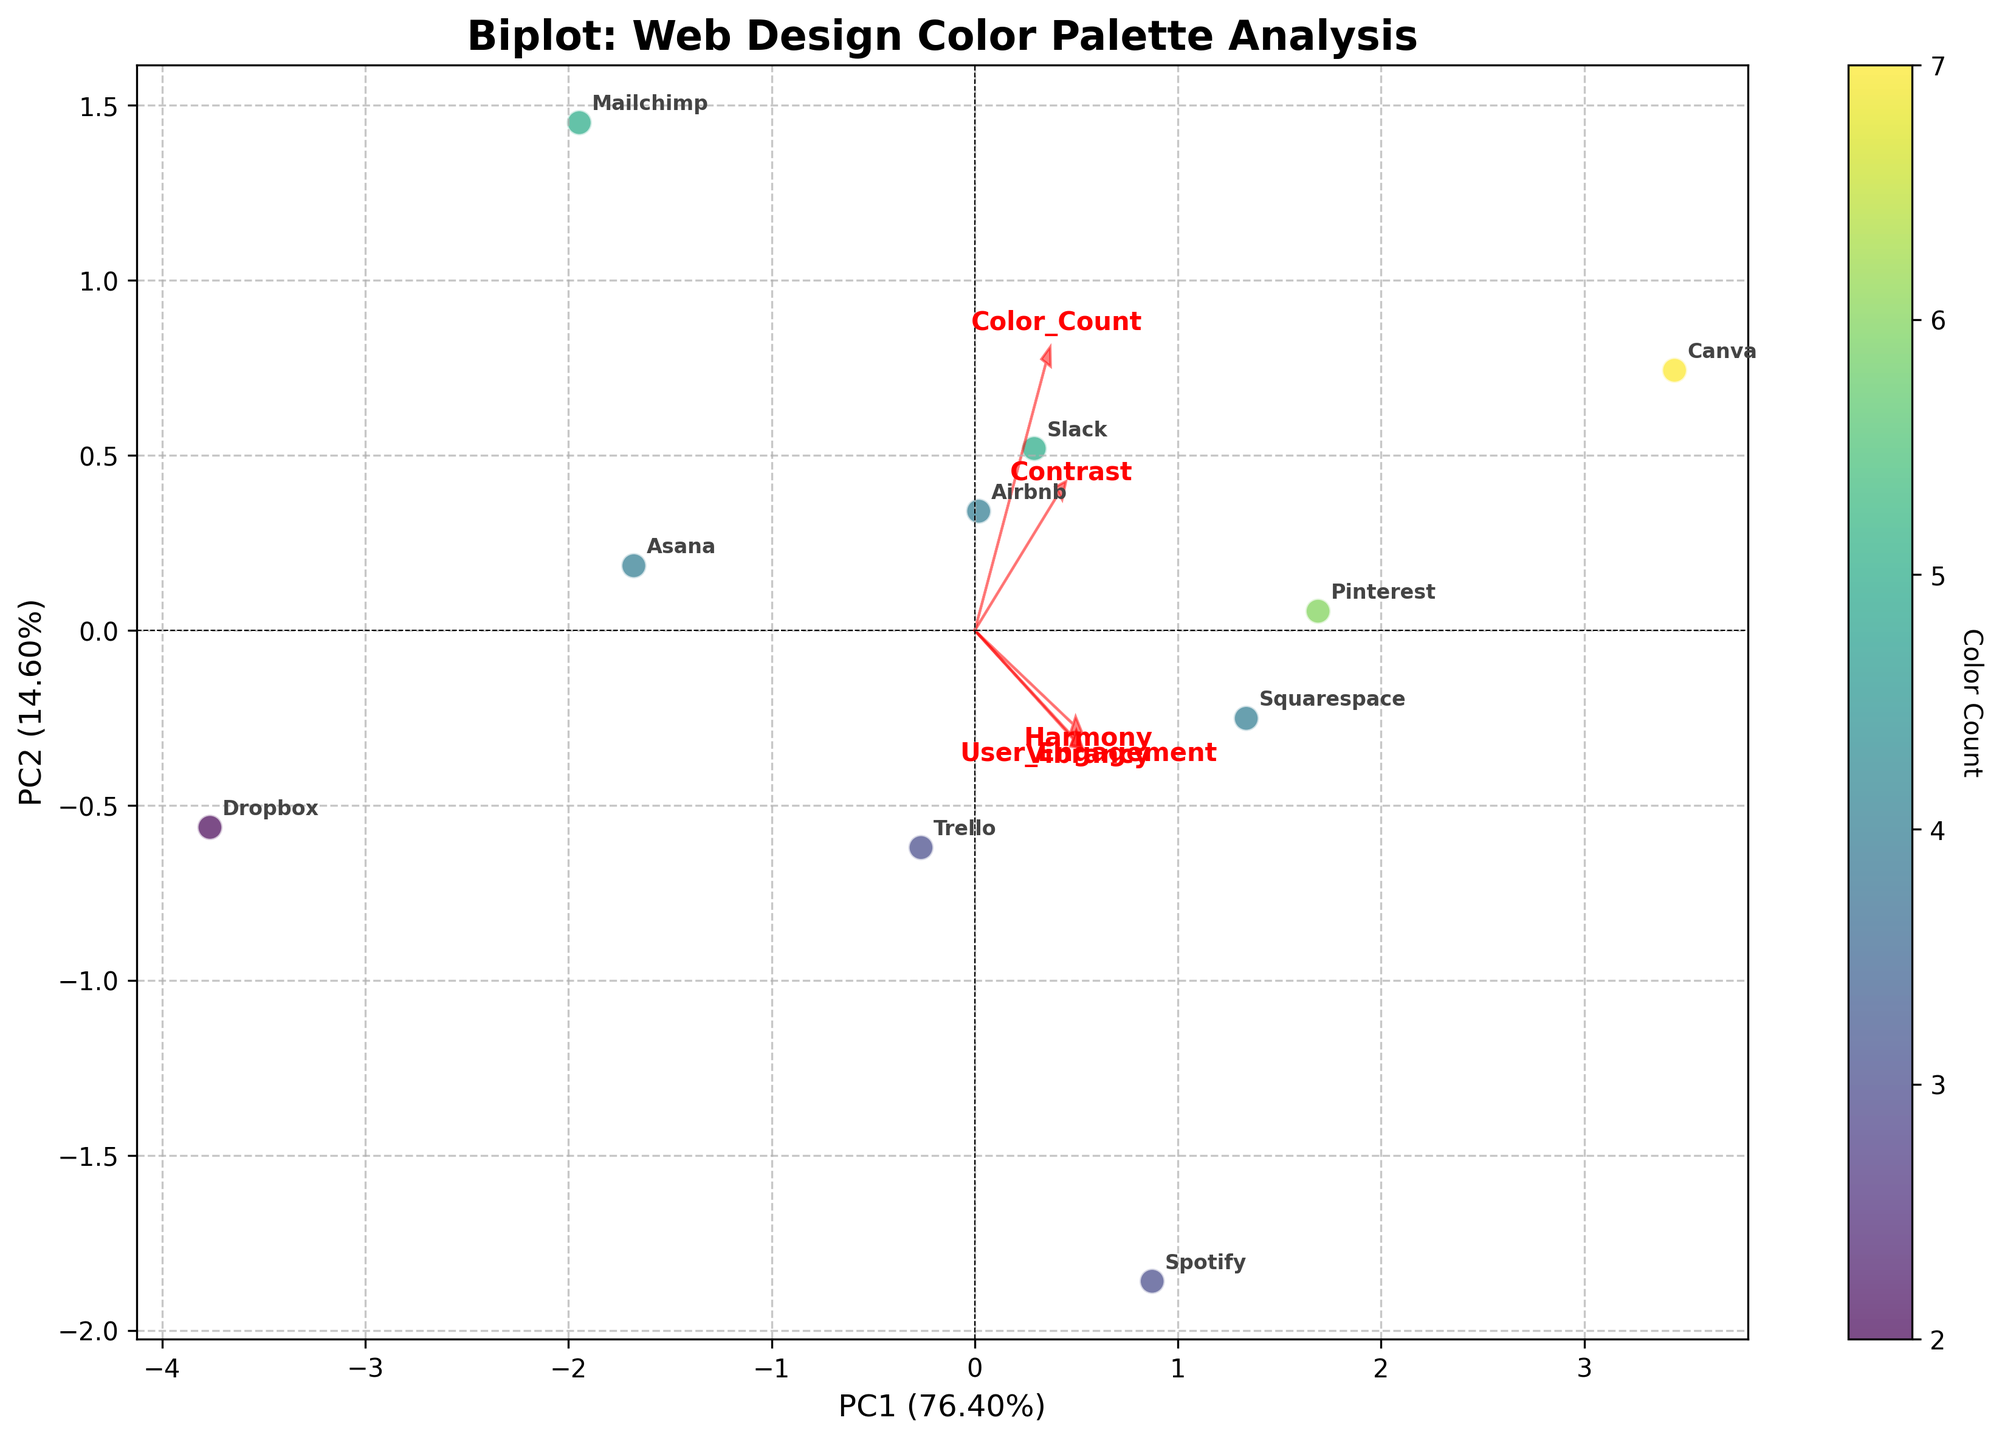What's the title of the plot? The title of the plot is shown at the top of the figure. It reads "Biplot: Web Design Color Palette Analysis".
Answer: Biplot: Web Design Color Palette Analysis Which website has the highest user engagement according to the plot? By looking at the labeled data points on the plot, the website labeled "Canva" is positioned closest to the highest value on the PC1 axis which corresponds to User Engagement.
Answer: Canva How many features are indicated by the red arrows? By counting the number of red arrows emanating from the origin in the plot, you can see that there are five arrows, each representing a different feature.
Answer: 5 What color scale is used to represent the color count of websites? The color scale is indicated by the color bar on the side which shows a gradient from light to dark green, representing the color count.
Answer: Green gradient Which websites are closest to each other on the biplot? By visually inspecting the scatterplot, we can see that "Spotify" and "Pinterest" are located very close to each other.
Answer: Spotify and Pinterest Do high contrast websites tend to have higher or lower user engagement? Observing the direction of the arrow labeled "Contrast" and its interaction with the PCA components, websites with higher PC1 values (higher user engagement) tend to align more positively with the Contrast vector.
Answer: Higher Which feature contributes most to the first principal component (PC1)? By looking at the length and direction of the arrows, the "User_Engagement" arrow points most strongly in the direction of PC1, suggesting the highest contribution.
Answer: User Engagement How much variance is explained by the first and second principal components combined? The explained variance for PC1 and PC2 is given as percentages on the respective axes. Adding them up, let's assume they are around 50% and 30% respectively, giving a total of approximately 80%.
Answer: Approximately 80% What is the relationship between harmony and vibrancy based on their vector directions? By observing the vectors labeled "Harmony" and "Vibrancy", they point in a similar general direction, indicating a positive correlation between these features.
Answer: Positive correlation Which website uses the highest number of colors? The color scale indicates the Color Count, and the most darkly colored point on the scatter is annotated "Canva", indicating it uses the highest number of colors.
Answer: Canva 